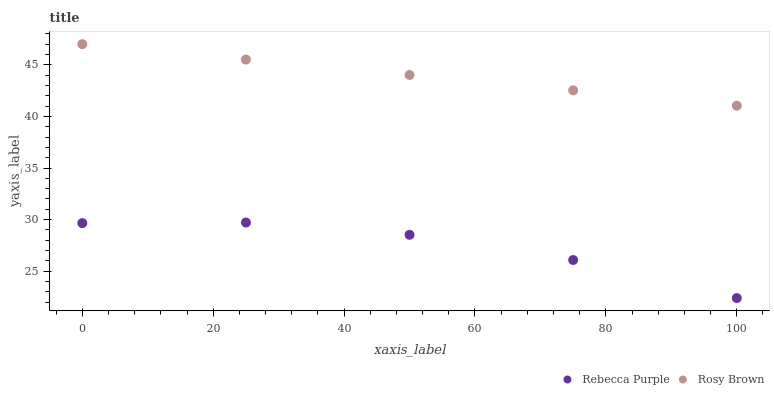Does Rebecca Purple have the minimum area under the curve?
Answer yes or no. Yes. Does Rosy Brown have the maximum area under the curve?
Answer yes or no. Yes. Does Rebecca Purple have the maximum area under the curve?
Answer yes or no. No. Is Rosy Brown the smoothest?
Answer yes or no. Yes. Is Rebecca Purple the roughest?
Answer yes or no. Yes. Is Rebecca Purple the smoothest?
Answer yes or no. No. Does Rebecca Purple have the lowest value?
Answer yes or no. Yes. Does Rosy Brown have the highest value?
Answer yes or no. Yes. Does Rebecca Purple have the highest value?
Answer yes or no. No. Is Rebecca Purple less than Rosy Brown?
Answer yes or no. Yes. Is Rosy Brown greater than Rebecca Purple?
Answer yes or no. Yes. Does Rebecca Purple intersect Rosy Brown?
Answer yes or no. No. 